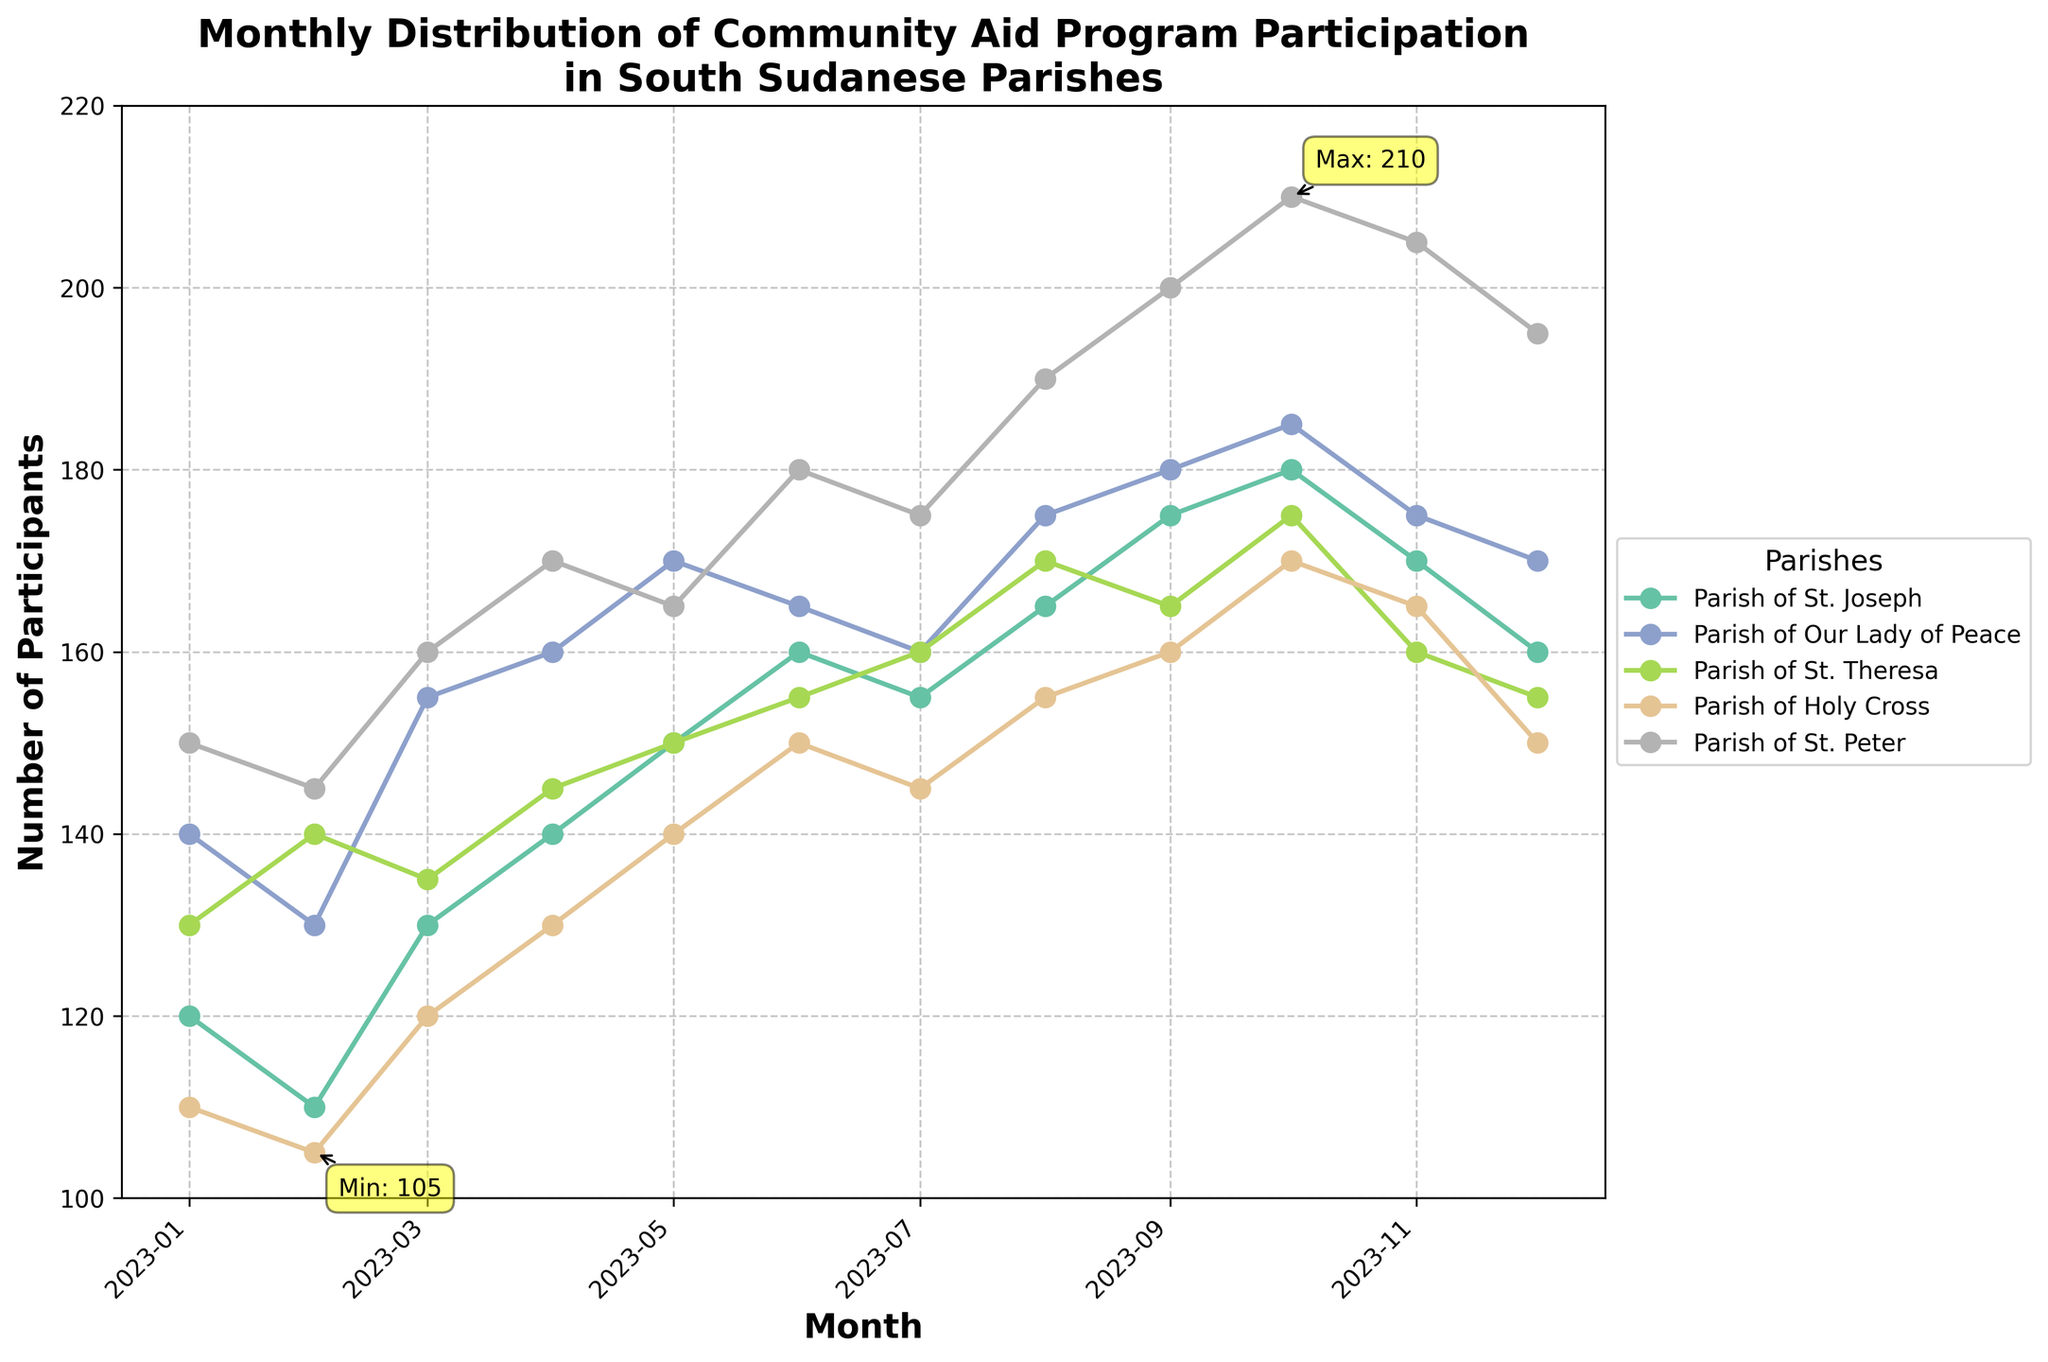What is the title of the figure? The title is generally located at the top of the figure, and it provides a summary of what the figure is about. In this case, it states the purpose and context of the data.
Answer: Monthly Distribution of Community Aid Program Participation in South Sudanese Parishes What are the x and y axes labeled? The x-axis represents time in the form of months, and the y-axis represents the number of participants in the community aid programs. The labels are usually found at the ends of the axes.
Answer: x-axis: Month, y-axis: Number of Participants Which parish had the highest number of participants in October 2023? Looking at October 2023 and finding the highest point on the y-axis for that month will show which parish had the highest participation. The corresponding color and legend will identify the parish.
Answer: Parish of St. Peter In which month did the Parish of Our Lady of Peace have its peak participation? By following the line for the Parish of Our Lady of Peace (identified by its color), we can see when it hits its highest point on the y-axis. The x-axis will indicate the corresponding month.
Answer: April 2023 What is the smallest number of participants recorded in any parish and in which month did it occur? The annotation "Min" in the figure marks the lowest point of the number of participants, along with the month.
Answer: 105 in February 2023 How does the participation in Parish of St. Joseph in January 2023 compare to that in December 2023? Finding the y-values corresponding to January and December for the Parish of St. Joseph and comparing them will show the change in participation.
Answer: January: 120, December: 160 Which parish showed a continuous increase in participation from January to October 2023? By examining the trends of the lines for each parish, we can identify which one shows a steady upward slope without dips.
Answer: Parish of St. Peter What is the average number of participants in the Parish of Holy Cross for the first six months of 2023? Identify the number of participants for the Parish of Holy Cross from January to June and calculate their average. Adding the participation numbers (110 + 105 + 120 + 130 + 140 + 150) and dividing by 6 provides the average.
Answer: (110 + 105 + 120 + 130 + 140 + 150) / 6 = 125 Which parish experienced the largest increase in participants from February to March 2023? Calculate the difference in participants between February and March for each parish and compare to find the largest increment.
Answer: Parish of Our Lady of Peace (155 - 130 = 25) Which month had the highest total number of participants across all parishes? Sum the number of participants for all parishes for each month and identify the month with the highest total. Summing the values for each month and comparing will reveal the highest month.
Answer: October 2023 (180 + 185 + 175 + 170 + 210 = 920) 